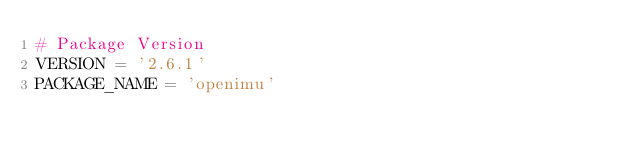<code> <loc_0><loc_0><loc_500><loc_500><_Python_># Package Version
VERSION = '2.6.1'
PACKAGE_NAME = 'openimu'
</code> 